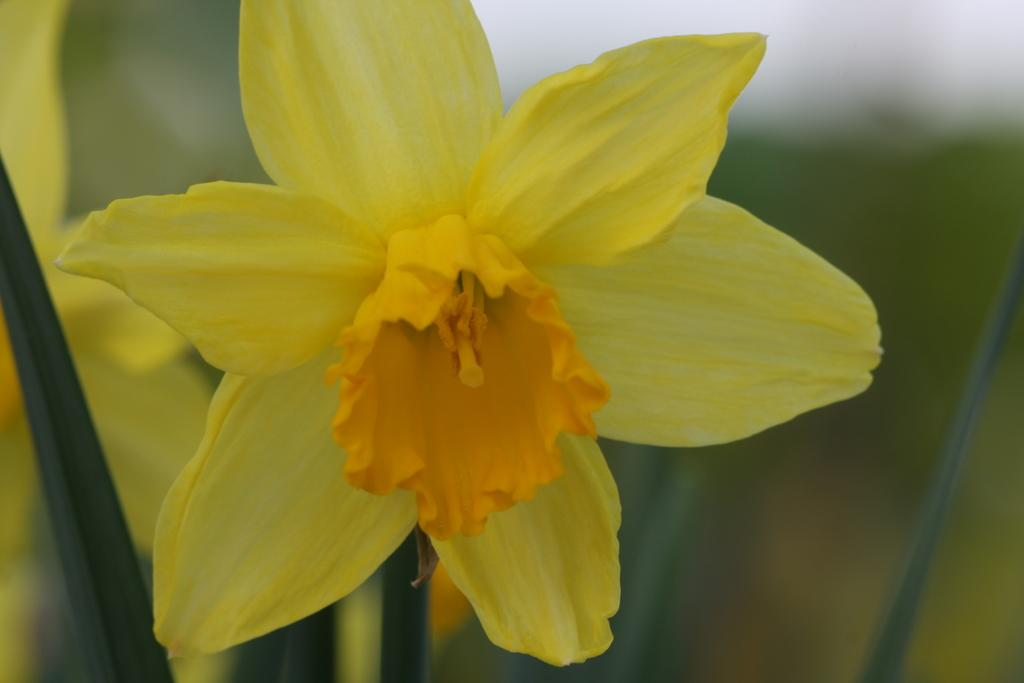How many flowers can be seen in the image? There are two flowers in the image. What else can be seen in the image besides the flowers? There are leaves in the image. Can you describe the background of the image? The background of the image is blurred. What type of screw can be seen in the image? There is no screw present in the image; it features two flowers and leaves. Is there an oven visible in the image? No, there is no oven present in the image. 